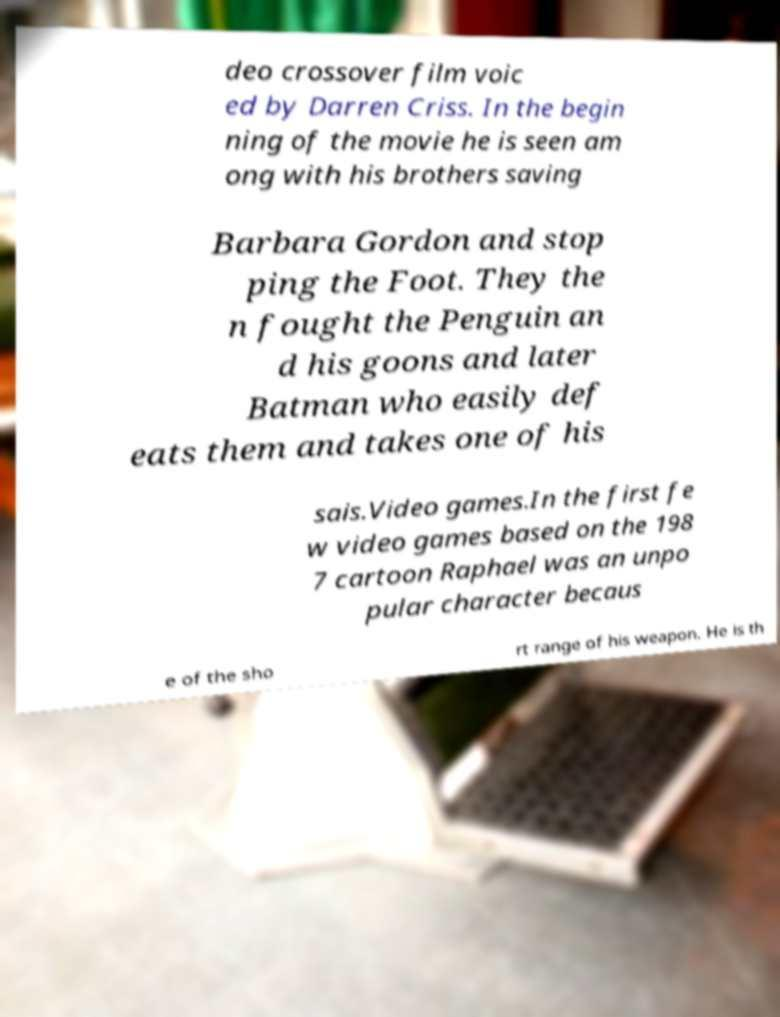There's text embedded in this image that I need extracted. Can you transcribe it verbatim? deo crossover film voic ed by Darren Criss. In the begin ning of the movie he is seen am ong with his brothers saving Barbara Gordon and stop ping the Foot. They the n fought the Penguin an d his goons and later Batman who easily def eats them and takes one of his sais.Video games.In the first fe w video games based on the 198 7 cartoon Raphael was an unpo pular character becaus e of the sho rt range of his weapon. He is th 